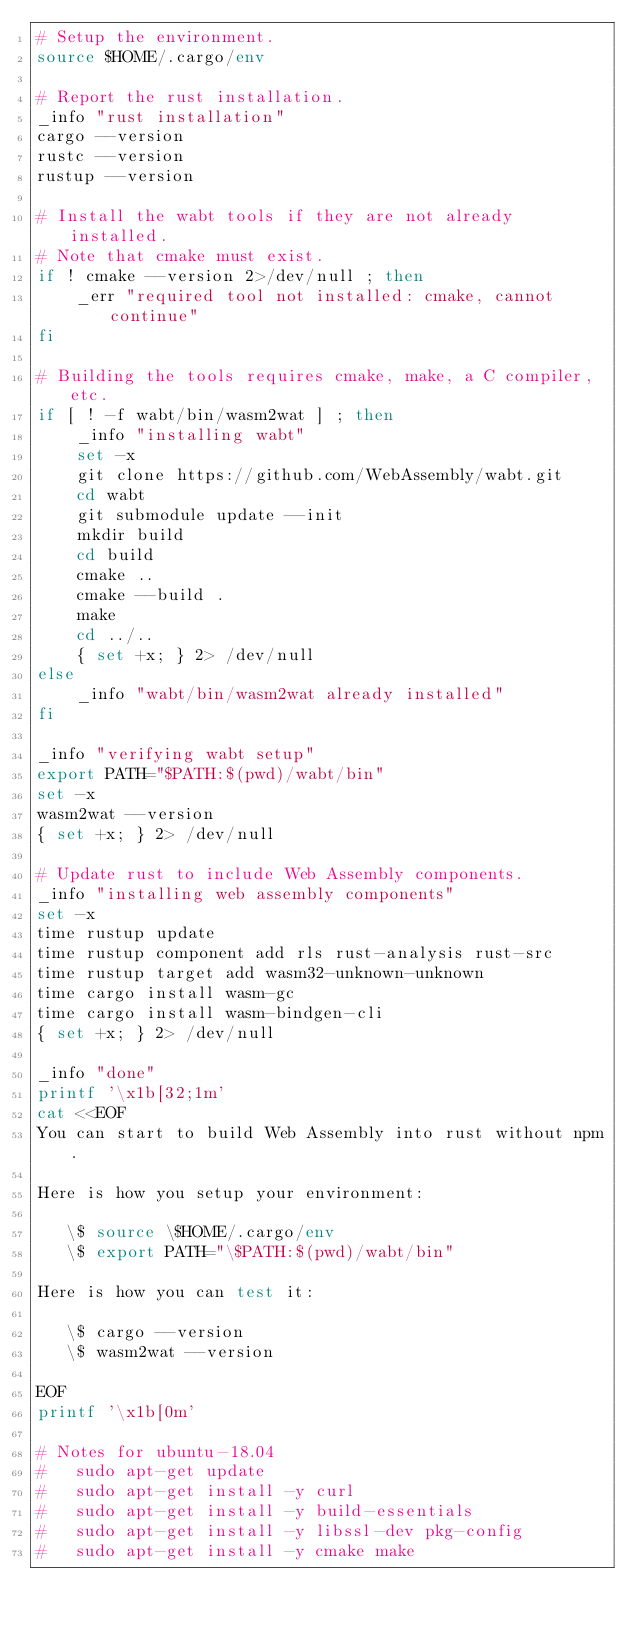<code> <loc_0><loc_0><loc_500><loc_500><_Bash_># Setup the environment.
source $HOME/.cargo/env

# Report the rust installation.
_info "rust installation"
cargo --version
rustc --version
rustup --version

# Install the wabt tools if they are not already installed.
# Note that cmake must exist.
if ! cmake --version 2>/dev/null ; then
    _err "required tool not installed: cmake, cannot continue"
fi

# Building the tools requires cmake, make, a C compiler, etc.
if [ ! -f wabt/bin/wasm2wat ] ; then
    _info "installing wabt"
    set -x
    git clone https://github.com/WebAssembly/wabt.git
    cd wabt
    git submodule update --init
    mkdir build
    cd build
    cmake ..
    cmake --build .
    make
    cd ../..
    { set +x; } 2> /dev/null
else
    _info "wabt/bin/wasm2wat already installed"
fi

_info "verifying wabt setup"
export PATH="$PATH:$(pwd)/wabt/bin"
set -x
wasm2wat --version
{ set +x; } 2> /dev/null

# Update rust to include Web Assembly components.
_info "installing web assembly components"
set -x
time rustup update
time rustup component add rls rust-analysis rust-src
time rustup target add wasm32-unknown-unknown
time cargo install wasm-gc
time cargo install wasm-bindgen-cli
{ set +x; } 2> /dev/null

_info "done"
printf '\x1b[32;1m'
cat <<EOF
You can start to build Web Assembly into rust without npm.

Here is how you setup your environment:

   \$ source \$HOME/.cargo/env
   \$ export PATH="\$PATH:$(pwd)/wabt/bin"

Here is how you can test it:

   \$ cargo --version
   \$ wasm2wat --version

EOF
printf '\x1b[0m'

# Notes for ubuntu-18.04
#   sudo apt-get update
#   sudo apt-get install -y curl
#   sudo apt-get install -y build-essentials
#   sudo apt-get install -y libssl-dev pkg-config
#   sudo apt-get install -y cmake make
</code> 